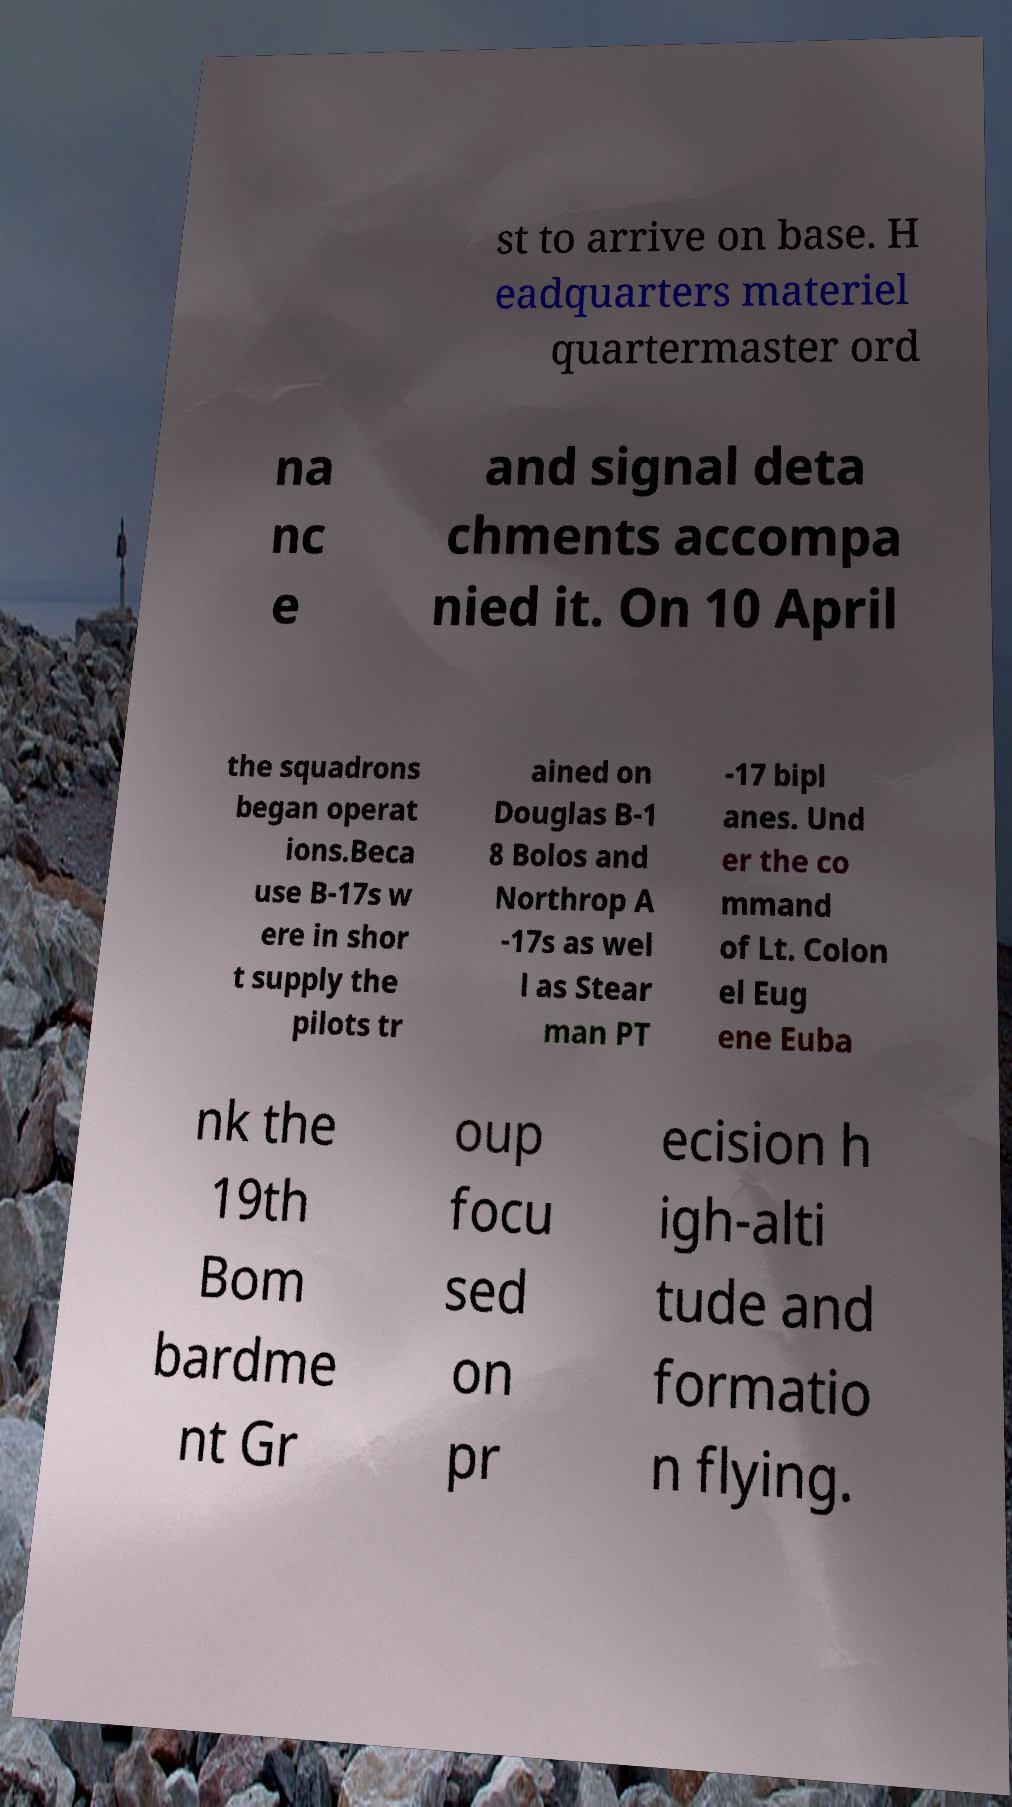For documentation purposes, I need the text within this image transcribed. Could you provide that? st to arrive on base. H eadquarters materiel quartermaster ord na nc e and signal deta chments accompa nied it. On 10 April the squadrons began operat ions.Beca use B-17s w ere in shor t supply the pilots tr ained on Douglas B-1 8 Bolos and Northrop A -17s as wel l as Stear man PT -17 bipl anes. Und er the co mmand of Lt. Colon el Eug ene Euba nk the 19th Bom bardme nt Gr oup focu sed on pr ecision h igh-alti tude and formatio n flying. 